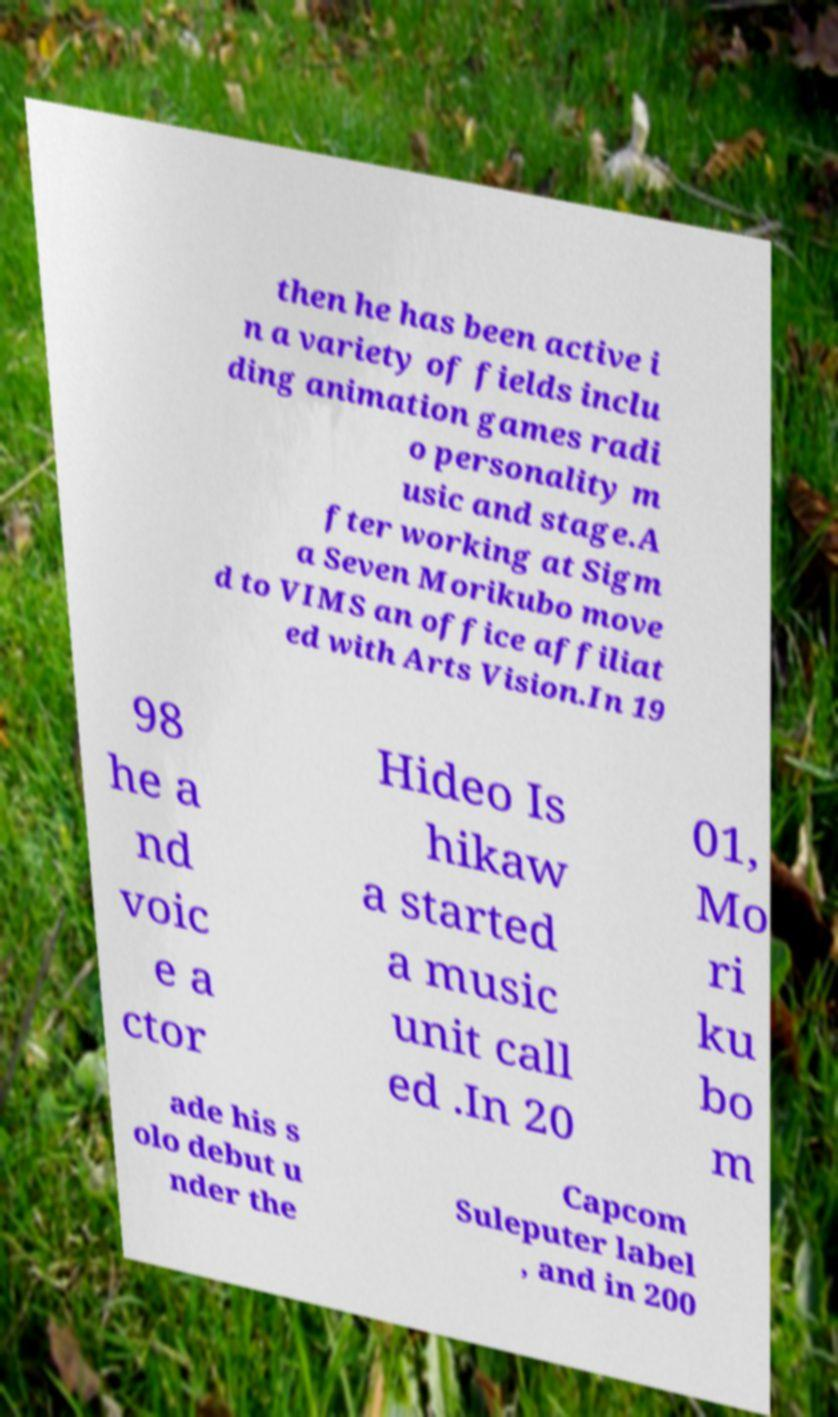Could you assist in decoding the text presented in this image and type it out clearly? then he has been active i n a variety of fields inclu ding animation games radi o personality m usic and stage.A fter working at Sigm a Seven Morikubo move d to VIMS an office affiliat ed with Arts Vision.In 19 98 he a nd voic e a ctor Hideo Is hikaw a started a music unit call ed .In 20 01, Mo ri ku bo m ade his s olo debut u nder the Capcom Suleputer label , and in 200 